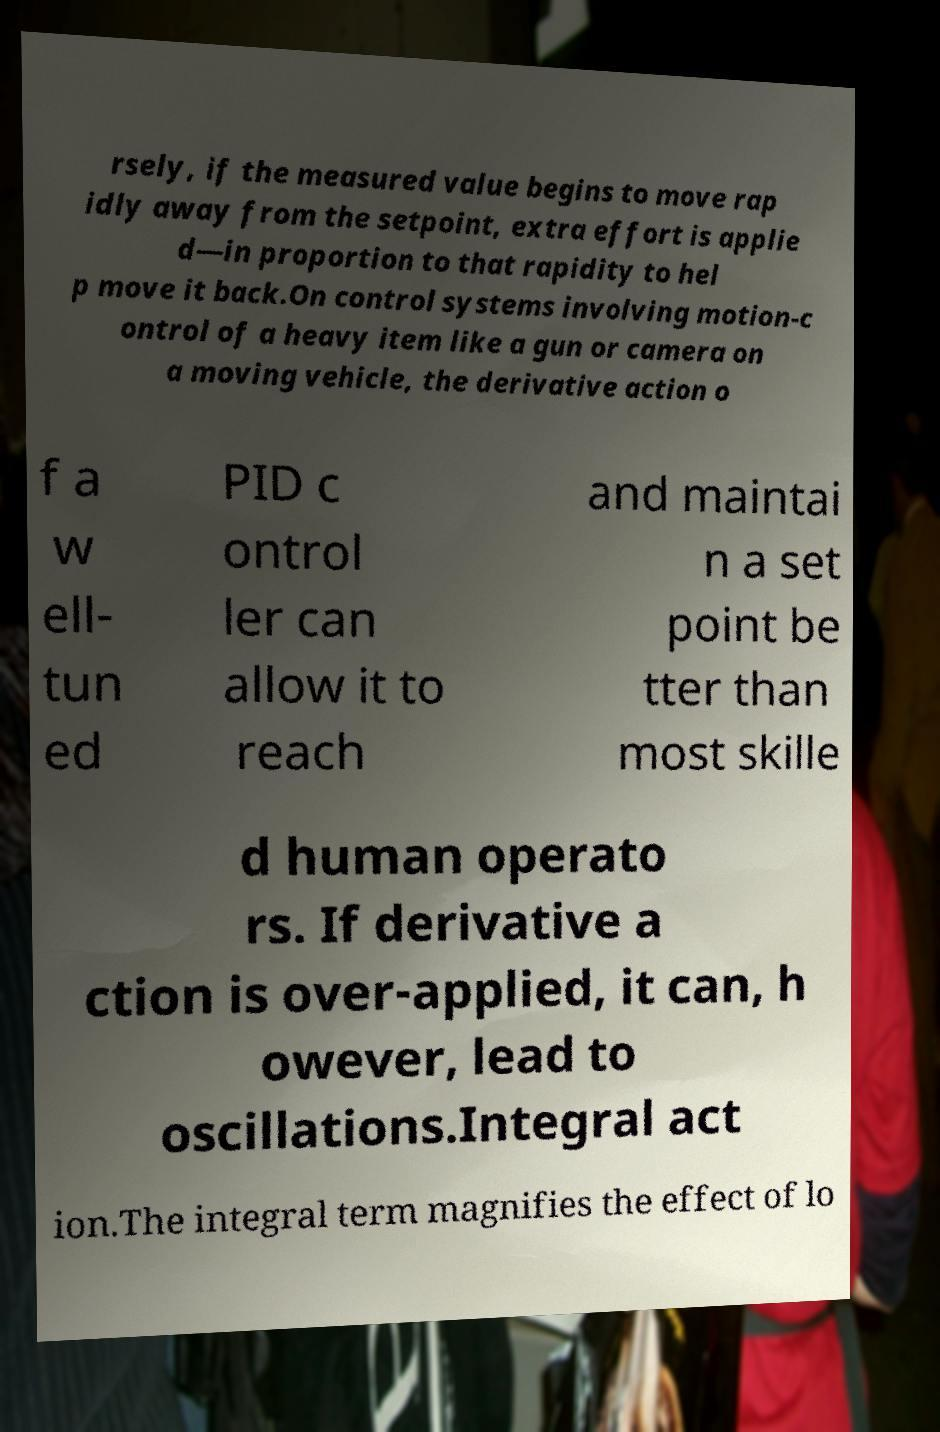For documentation purposes, I need the text within this image transcribed. Could you provide that? rsely, if the measured value begins to move rap idly away from the setpoint, extra effort is applie d—in proportion to that rapidity to hel p move it back.On control systems involving motion-c ontrol of a heavy item like a gun or camera on a moving vehicle, the derivative action o f a w ell- tun ed PID c ontrol ler can allow it to reach and maintai n a set point be tter than most skille d human operato rs. If derivative a ction is over-applied, it can, h owever, lead to oscillations.Integral act ion.The integral term magnifies the effect of lo 